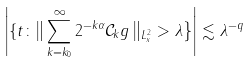Convert formula to latex. <formula><loc_0><loc_0><loc_500><loc_500>\left | \left \{ t \colon \right \| \sum _ { k = k _ { 0 } } ^ { \infty } 2 ^ { - k \alpha } \mathcal { C } _ { k } g \left \| _ { L ^ { 2 } _ { x } } > \lambda \right \} \right | \lesssim \lambda ^ { - q }</formula> 